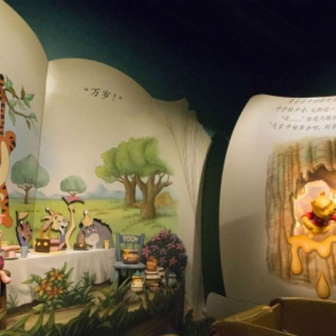Can you describe the clothing and pose of each character? Sure! Winnie the Pooh is wearing his iconic red shirt and appears to be extending his hand towards a honey pot on a picnic table. Tigger is in an energetic mid-leap, his body stretched out dynamically, displaying his vibrant orange fur with black stripes. Piglet, dressed in his usual striped outfit, is standing to Pooh's left, looking shy and timid. Eeyore, the gray donkey, stands to the right of the group, his head and posture reflecting his usual gloomy demeanor. What is the significance of the tree in the background? The tree in the background of the mural is significant as it represents the Hundred Acre Wood, the home of Winnie the Pooh and his friends. It is a central and unifying element in their many adventures. The towering tree with its lush green leaves symbolizes nature and the simple, idyllic life that Pooh and his friends enjoy. Its presence in the mural not only sets the scene but also enhances the whimsical, pastoral atmosphere of the classic tales. Imagine if the characters could talk about the mural. What might they say? Pooh might say, 'Why, it looks like a honey-filled dream! I can almost taste that honey pot!' Tigger, bouncing with excitement, would likely add, 'Look at me go! What a wonderful leap. The more bounces the merrier!' Piglet, in a soft, tentative voice, might say, 'Oh dear, I hope I look alright. It's a bit overwhelming but also quite nice.' And Eeyore, with his characteristic gloom, could comment, 'It’s just a painting, but at least it’s a nice one. Seen better, but could be worse.' Describe a realistic scenario that could happen in this mural. One realistic scenario is that the characters are having a lovely picnic under the tree. Winnie the Pooh has brought his favorite honey pot, which he's eagerly reaching for. Tigger, full of energy, is bounding around, possibly chasing after a butterfly. Piglet is nervously arranging the picnic items, ensuring everything is perfect. Meanwhile, Eeyore is slightly detached, pondering quietly but still part of the friendly gathering. The setting sun casts a warm glow over the scene, adding to the idyllic, peaceful ambiance. Give a brief summary of another possible scenario. In another scenario, the friends are planning an adventure to explore the Hundred Acre Wood. Pooh suggests mapping out the journey while enjoying some honey. Tigger eagerly volunteers to lead the way with his enthusiastic bounds. Piglet, although nervous, agrees to join the expedition for the sake of his friends. Eeyore, as usual, is mildly indifferent but follows along, adding his quiet commentary to the group’s excitement. 